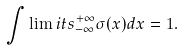Convert formula to latex. <formula><loc_0><loc_0><loc_500><loc_500>\int \lim i t s _ { - \infty } ^ { + \infty } \sigma ( x ) d x = 1 .</formula> 